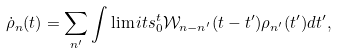<formula> <loc_0><loc_0><loc_500><loc_500>\dot { \rho } _ { n } ( t ) = \sum _ { n ^ { \prime } } \int \lim i t s _ { 0 } ^ { t } \mathcal { W } _ { n - n ^ { \prime } } ( t - t ^ { \prime } ) \rho _ { n ^ { \prime } } ( t ^ { \prime } ) d t ^ { \prime } ,</formula> 